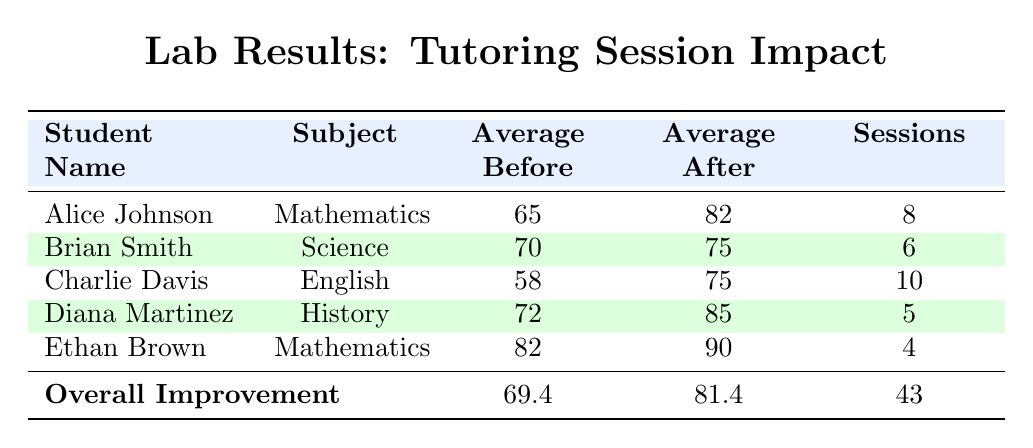What was Alice Johnson's average grade before tutoring? From the table, Alice Johnson's average grade before tutoring is directly listed under the "Average Before" column next to her name. It shows 65.
Answer: 65 What was the average grade after tutoring for Brian Smith? The table lists Brian Smith's average grade after tutoring under the "Average After" column, which shows 75.
Answer: 75 Did Charlie Davis improve more than Ethan Brown after tutoring? To compare improvements, we first find the difference between "Average After" and "Average Before" for both students. Charlie improved from 58 to 75, which is an increase of 17. Ethan improved from 82 to 90, an increase of 8. Since 17 > 8, Charlie improved more.
Answer: Yes What is the overall improvement in average grades before and after tutoring sessions? The overall improvement is found by looking at the "Overall Improvement" row in the table, where the average before tutoring is 69.4 and the average after tutoring is 81.4. The difference is 81.4 - 69.4 = 12.
Answer: 12 How many total sessions were attended by all students combined? The total number of sessions is found in the "Overall Improvement" row, indicated as 43. This is the sum of sessions attended by all students.
Answer: 43 Who had the highest average grade after tutoring, and what was it? By examining the "Average After" column for all students, we see that Diana Martinez has an average grade of 85, which is the highest.
Answer: 85 What is the average improvement in grades across all students? First, we need the improvements for each student: Alice (17), Brian (5), Charlie (17), Diana (13), Ethan (8). Summing these gives 60, and since there are 5 students, we divide by 5. Average improvement = 60 / 5 = 12.
Answer: 12 Was there any student who did not improve their grade after tutoring? Reviewing the "Average Before" and "Average After" columns for each student shows that all students have higher averages after tutoring compared to before, thus indicating that no one did not improve.
Answer: No What subject did Charlie Davis get tutored for? The table states that Charlie Davis was tutored in English, as listed in the "Subject" column next to his name.
Answer: English 